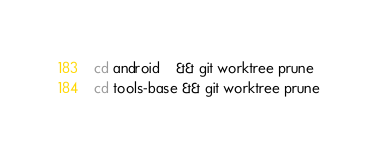<code> <loc_0><loc_0><loc_500><loc_500><_Bash_>cd android    && git worktree prune 
cd tools-base && git worktree prune</code> 